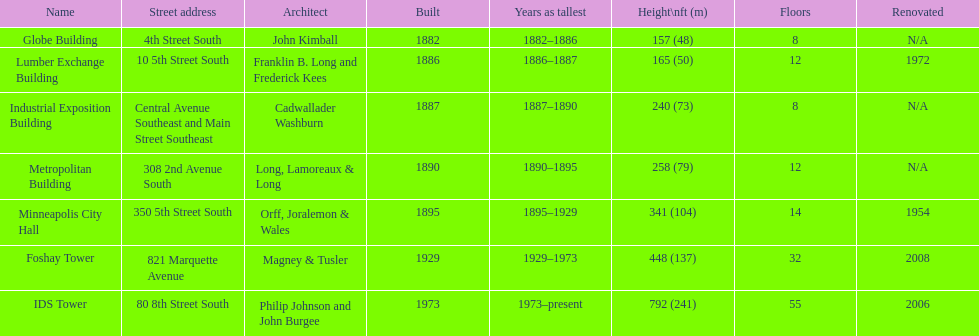After ids tower what is the second tallest building in minneapolis? Foshay Tower. Would you be able to parse every entry in this table? {'header': ['Name', 'Street address', 'Architect', 'Built', 'Years as tallest', 'Height\\nft (m)', 'Floors', 'Renovated'], 'rows': [['Globe Building', '4th Street South', 'John Kimball', '1882', '1882–1886', '157 (48)', '8', 'N/A'], ['Lumber Exchange Building', '10 5th Street South', 'Franklin B. Long and Frederick Kees', '1886', '1886–1887', '165 (50)', '12', '1972'], ['Industrial Exposition Building', 'Central Avenue Southeast and Main Street Southeast', 'Cadwallader Washburn', '1887', '1887–1890', '240 (73)', '8', 'N/A'], ['Metropolitan Building', '308 2nd Avenue South', 'Long, Lamoreaux & Long', '1890', '1890–1895', '258 (79)', '12', 'N/A'], ['Minneapolis City Hall', '350 5th Street South', 'Orff, Joralemon & Wales', '1895', '1895–1929', '341 (104)', '14', '1954'], ['Foshay Tower', '821 Marquette Avenue', 'Magney & Tusler', '1929', '1929–1973', '448 (137)', '32', '2008'], ['IDS Tower', '80 8th Street South', 'Philip Johnson and John Burgee', '1973', '1973–present', '792 (241)', '55', '2006']]} 